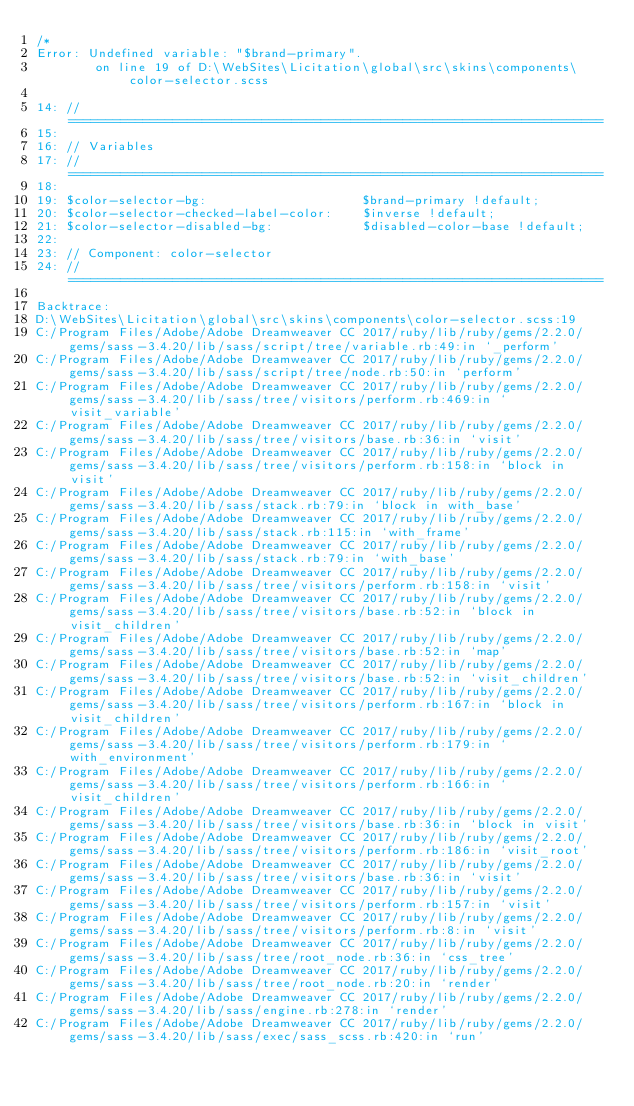<code> <loc_0><loc_0><loc_500><loc_500><_CSS_>/*
Error: Undefined variable: "$brand-primary".
        on line 19 of D:\WebSites\Licitation\global\src\skins\components\color-selector.scss

14: // ========================================================================
15: 
16: // Variables
17: // ========================================================================
18: 
19: $color-selector-bg:                     $brand-primary !default;
20: $color-selector-checked-label-color:    $inverse !default;
21: $color-selector-disabled-bg:            $disabled-color-base !default;
22: 
23: // Component: color-selector
24: // ========================================================================

Backtrace:
D:\WebSites\Licitation\global\src\skins\components\color-selector.scss:19
C:/Program Files/Adobe/Adobe Dreamweaver CC 2017/ruby/lib/ruby/gems/2.2.0/gems/sass-3.4.20/lib/sass/script/tree/variable.rb:49:in `_perform'
C:/Program Files/Adobe/Adobe Dreamweaver CC 2017/ruby/lib/ruby/gems/2.2.0/gems/sass-3.4.20/lib/sass/script/tree/node.rb:50:in `perform'
C:/Program Files/Adobe/Adobe Dreamweaver CC 2017/ruby/lib/ruby/gems/2.2.0/gems/sass-3.4.20/lib/sass/tree/visitors/perform.rb:469:in `visit_variable'
C:/Program Files/Adobe/Adobe Dreamweaver CC 2017/ruby/lib/ruby/gems/2.2.0/gems/sass-3.4.20/lib/sass/tree/visitors/base.rb:36:in `visit'
C:/Program Files/Adobe/Adobe Dreamweaver CC 2017/ruby/lib/ruby/gems/2.2.0/gems/sass-3.4.20/lib/sass/tree/visitors/perform.rb:158:in `block in visit'
C:/Program Files/Adobe/Adobe Dreamweaver CC 2017/ruby/lib/ruby/gems/2.2.0/gems/sass-3.4.20/lib/sass/stack.rb:79:in `block in with_base'
C:/Program Files/Adobe/Adobe Dreamweaver CC 2017/ruby/lib/ruby/gems/2.2.0/gems/sass-3.4.20/lib/sass/stack.rb:115:in `with_frame'
C:/Program Files/Adobe/Adobe Dreamweaver CC 2017/ruby/lib/ruby/gems/2.2.0/gems/sass-3.4.20/lib/sass/stack.rb:79:in `with_base'
C:/Program Files/Adobe/Adobe Dreamweaver CC 2017/ruby/lib/ruby/gems/2.2.0/gems/sass-3.4.20/lib/sass/tree/visitors/perform.rb:158:in `visit'
C:/Program Files/Adobe/Adobe Dreamweaver CC 2017/ruby/lib/ruby/gems/2.2.0/gems/sass-3.4.20/lib/sass/tree/visitors/base.rb:52:in `block in visit_children'
C:/Program Files/Adobe/Adobe Dreamweaver CC 2017/ruby/lib/ruby/gems/2.2.0/gems/sass-3.4.20/lib/sass/tree/visitors/base.rb:52:in `map'
C:/Program Files/Adobe/Adobe Dreamweaver CC 2017/ruby/lib/ruby/gems/2.2.0/gems/sass-3.4.20/lib/sass/tree/visitors/base.rb:52:in `visit_children'
C:/Program Files/Adobe/Adobe Dreamweaver CC 2017/ruby/lib/ruby/gems/2.2.0/gems/sass-3.4.20/lib/sass/tree/visitors/perform.rb:167:in `block in visit_children'
C:/Program Files/Adobe/Adobe Dreamweaver CC 2017/ruby/lib/ruby/gems/2.2.0/gems/sass-3.4.20/lib/sass/tree/visitors/perform.rb:179:in `with_environment'
C:/Program Files/Adobe/Adobe Dreamweaver CC 2017/ruby/lib/ruby/gems/2.2.0/gems/sass-3.4.20/lib/sass/tree/visitors/perform.rb:166:in `visit_children'
C:/Program Files/Adobe/Adobe Dreamweaver CC 2017/ruby/lib/ruby/gems/2.2.0/gems/sass-3.4.20/lib/sass/tree/visitors/base.rb:36:in `block in visit'
C:/Program Files/Adobe/Adobe Dreamweaver CC 2017/ruby/lib/ruby/gems/2.2.0/gems/sass-3.4.20/lib/sass/tree/visitors/perform.rb:186:in `visit_root'
C:/Program Files/Adobe/Adobe Dreamweaver CC 2017/ruby/lib/ruby/gems/2.2.0/gems/sass-3.4.20/lib/sass/tree/visitors/base.rb:36:in `visit'
C:/Program Files/Adobe/Adobe Dreamweaver CC 2017/ruby/lib/ruby/gems/2.2.0/gems/sass-3.4.20/lib/sass/tree/visitors/perform.rb:157:in `visit'
C:/Program Files/Adobe/Adobe Dreamweaver CC 2017/ruby/lib/ruby/gems/2.2.0/gems/sass-3.4.20/lib/sass/tree/visitors/perform.rb:8:in `visit'
C:/Program Files/Adobe/Adobe Dreamweaver CC 2017/ruby/lib/ruby/gems/2.2.0/gems/sass-3.4.20/lib/sass/tree/root_node.rb:36:in `css_tree'
C:/Program Files/Adobe/Adobe Dreamweaver CC 2017/ruby/lib/ruby/gems/2.2.0/gems/sass-3.4.20/lib/sass/tree/root_node.rb:20:in `render'
C:/Program Files/Adobe/Adobe Dreamweaver CC 2017/ruby/lib/ruby/gems/2.2.0/gems/sass-3.4.20/lib/sass/engine.rb:278:in `render'
C:/Program Files/Adobe/Adobe Dreamweaver CC 2017/ruby/lib/ruby/gems/2.2.0/gems/sass-3.4.20/lib/sass/exec/sass_scss.rb:420:in `run'</code> 